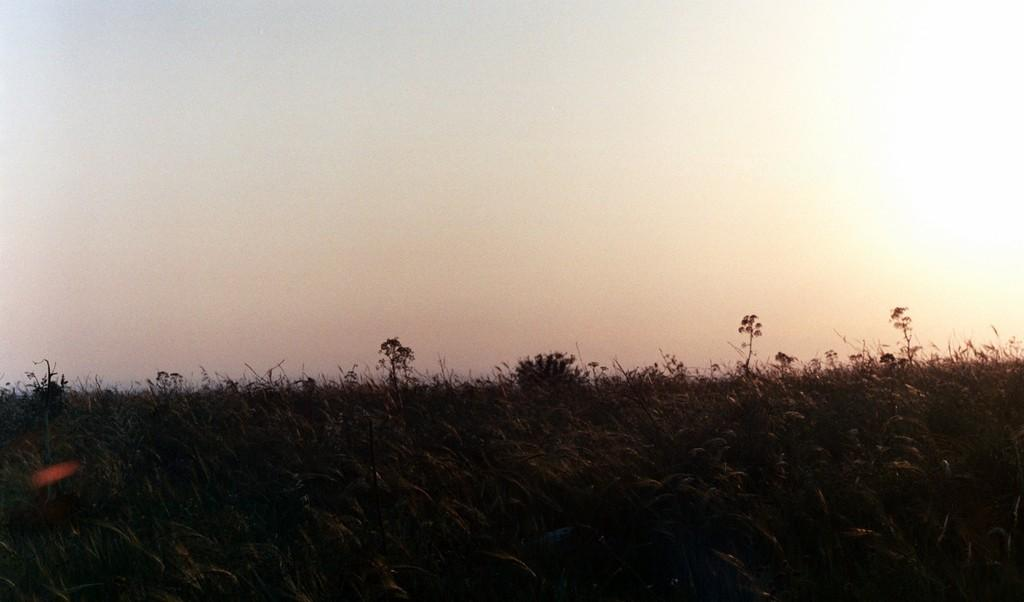What is located in the foreground of the image? There are plants in the foreground of the image. What can be seen in the background of the image? The sky is visible in the background of the image. What type of oatmeal is being prepared by the farmer in the image? There is no farmer or oatmeal present in the image; it only features plants and a clear sky. 